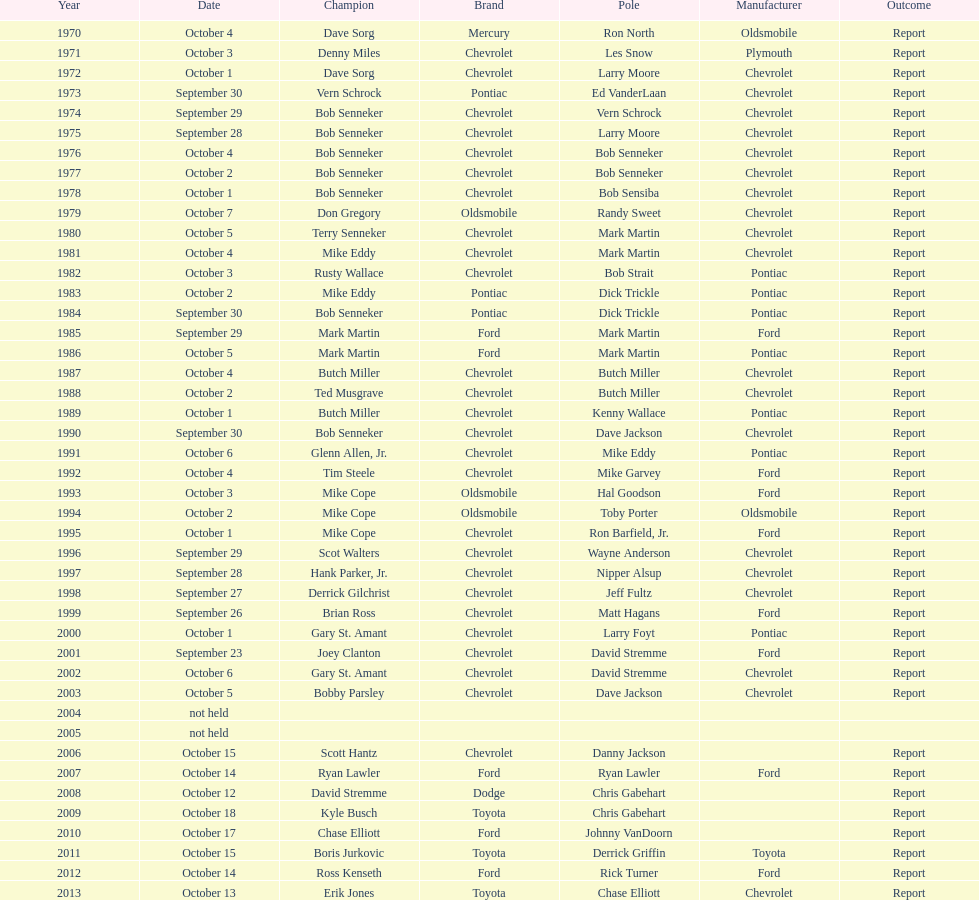Which make was used the least? Mercury. 